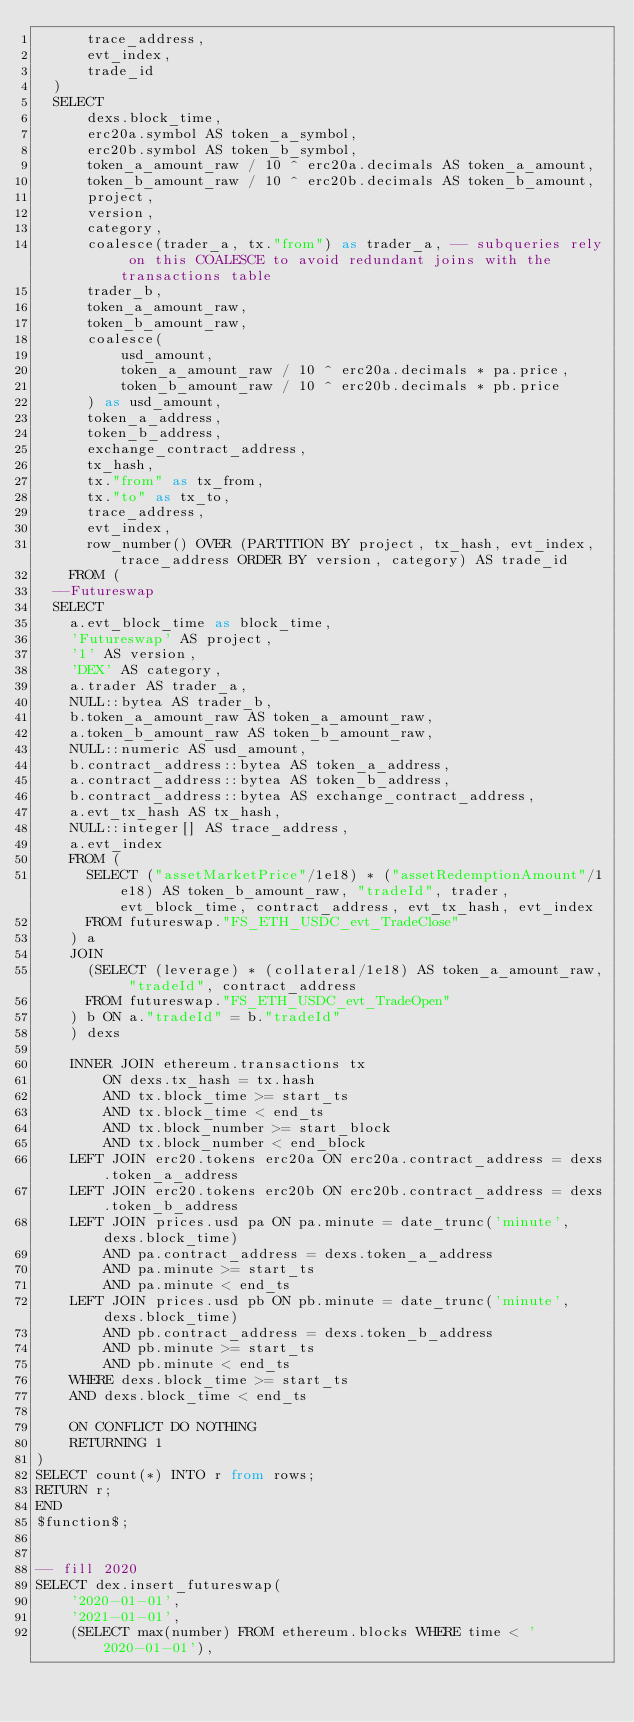Convert code to text. <code><loc_0><loc_0><loc_500><loc_500><_SQL_>      trace_address,
      evt_index,
      trade_id
  )
  SELECT
      dexs.block_time,
      erc20a.symbol AS token_a_symbol,
      erc20b.symbol AS token_b_symbol,
      token_a_amount_raw / 10 ^ erc20a.decimals AS token_a_amount,
      token_b_amount_raw / 10 ^ erc20b.decimals AS token_b_amount,
      project,
      version,
      category,
      coalesce(trader_a, tx."from") as trader_a, -- subqueries rely on this COALESCE to avoid redundant joins with the transactions table
      trader_b,
      token_a_amount_raw,
      token_b_amount_raw,
      coalesce(
          usd_amount,
          token_a_amount_raw / 10 ^ erc20a.decimals * pa.price,
          token_b_amount_raw / 10 ^ erc20b.decimals * pb.price
      ) as usd_amount,
      token_a_address,
      token_b_address,
      exchange_contract_address,
      tx_hash,
      tx."from" as tx_from,
      tx."to" as tx_to,
      trace_address,
      evt_index,
      row_number() OVER (PARTITION BY project, tx_hash, evt_index, trace_address ORDER BY version, category) AS trade_id
    FROM (
  --Futureswap
  SELECT
    a.evt_block_time as block_time,
    'Futureswap' AS project,
    '1' AS version,
    'DEX' AS category,
    a.trader AS trader_a,
    NULL::bytea AS trader_b,
    b.token_a_amount_raw AS token_a_amount_raw,
    a.token_b_amount_raw AS token_b_amount_raw,
    NULL::numeric AS usd_amount,
    b.contract_address::bytea AS token_a_address,
    a.contract_address::bytea AS token_b_address,
    b.contract_address::bytea AS exchange_contract_address,
    a.evt_tx_hash AS tx_hash,
    NULL::integer[] AS trace_address,
    a.evt_index
    FROM (
      SELECT ("assetMarketPrice"/1e18) * ("assetRedemptionAmount"/1e18) AS token_b_amount_raw, "tradeId", trader, evt_block_time, contract_address, evt_tx_hash, evt_index
      FROM futureswap."FS_ETH_USDC_evt_TradeClose"
    ) a
    JOIN
      (SELECT (leverage) * (collateral/1e18) AS token_a_amount_raw, "tradeId", contract_address
      FROM futureswap."FS_ETH_USDC_evt_TradeOpen"
    ) b ON a."tradeId" = b."tradeId"
    ) dexs

    INNER JOIN ethereum.transactions tx
        ON dexs.tx_hash = tx.hash
        AND tx.block_time >= start_ts
        AND tx.block_time < end_ts
        AND tx.block_number >= start_block
        AND tx.block_number < end_block
    LEFT JOIN erc20.tokens erc20a ON erc20a.contract_address = dexs.token_a_address
    LEFT JOIN erc20.tokens erc20b ON erc20b.contract_address = dexs.token_b_address
    LEFT JOIN prices.usd pa ON pa.minute = date_trunc('minute', dexs.block_time)
        AND pa.contract_address = dexs.token_a_address
        AND pa.minute >= start_ts
        AND pa.minute < end_ts
    LEFT JOIN prices.usd pb ON pb.minute = date_trunc('minute', dexs.block_time)
        AND pb.contract_address = dexs.token_b_address
        AND pb.minute >= start_ts
        AND pb.minute < end_ts
    WHERE dexs.block_time >= start_ts
    AND dexs.block_time < end_ts

    ON CONFLICT DO NOTHING
    RETURNING 1
)
SELECT count(*) INTO r from rows;
RETURN r;
END
$function$;


-- fill 2020
SELECT dex.insert_futureswap(
    '2020-01-01',
    '2021-01-01',
    (SELECT max(number) FROM ethereum.blocks WHERE time < '2020-01-01'),</code> 